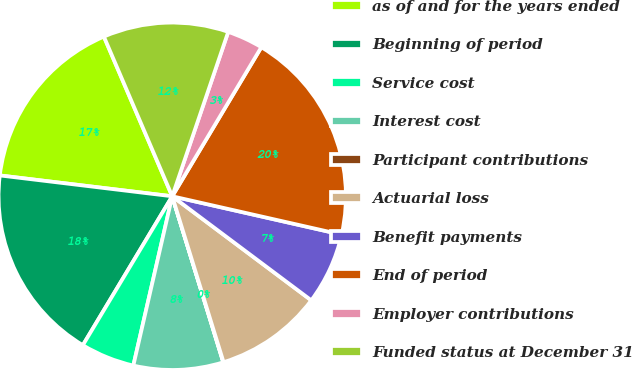Convert chart to OTSL. <chart><loc_0><loc_0><loc_500><loc_500><pie_chart><fcel>as of and for the years ended<fcel>Beginning of period<fcel>Service cost<fcel>Interest cost<fcel>Participant contributions<fcel>Actuarial loss<fcel>Benefit payments<fcel>End of period<fcel>Employer contributions<fcel>Funded status at December 31<nl><fcel>16.65%<fcel>18.31%<fcel>5.01%<fcel>8.34%<fcel>0.03%<fcel>10.0%<fcel>6.68%<fcel>19.97%<fcel>3.35%<fcel>11.66%<nl></chart> 